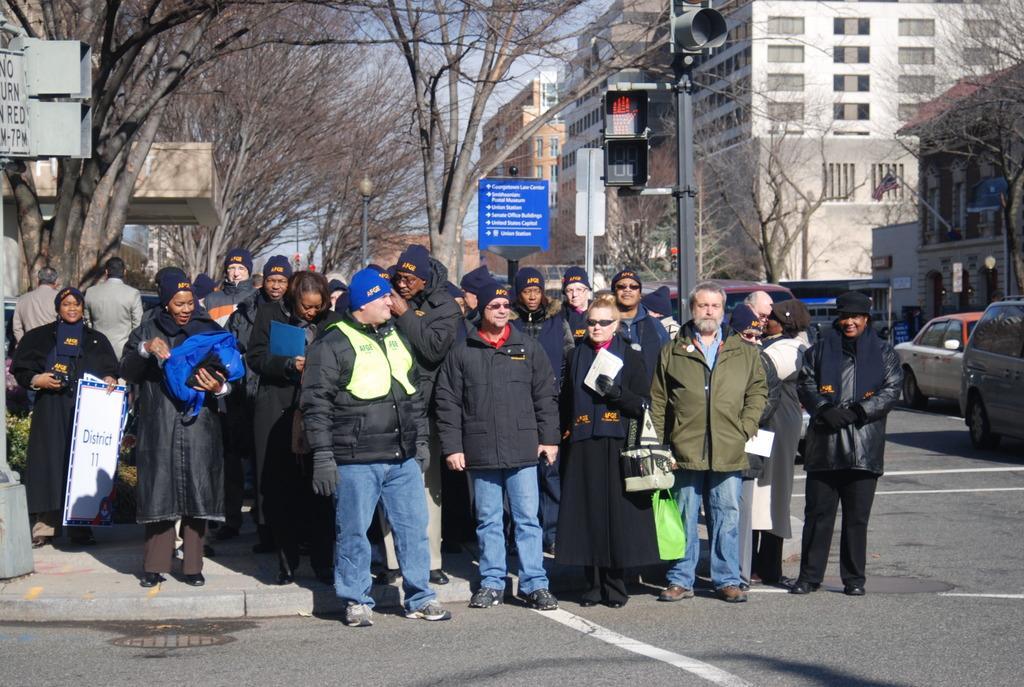In one or two sentences, can you explain what this image depicts? In this picture there are people and we can see boards, vehicles on the road, lights, traffic signals, poles, trees, flag and buildings. In the background of the image we can see the sky. 